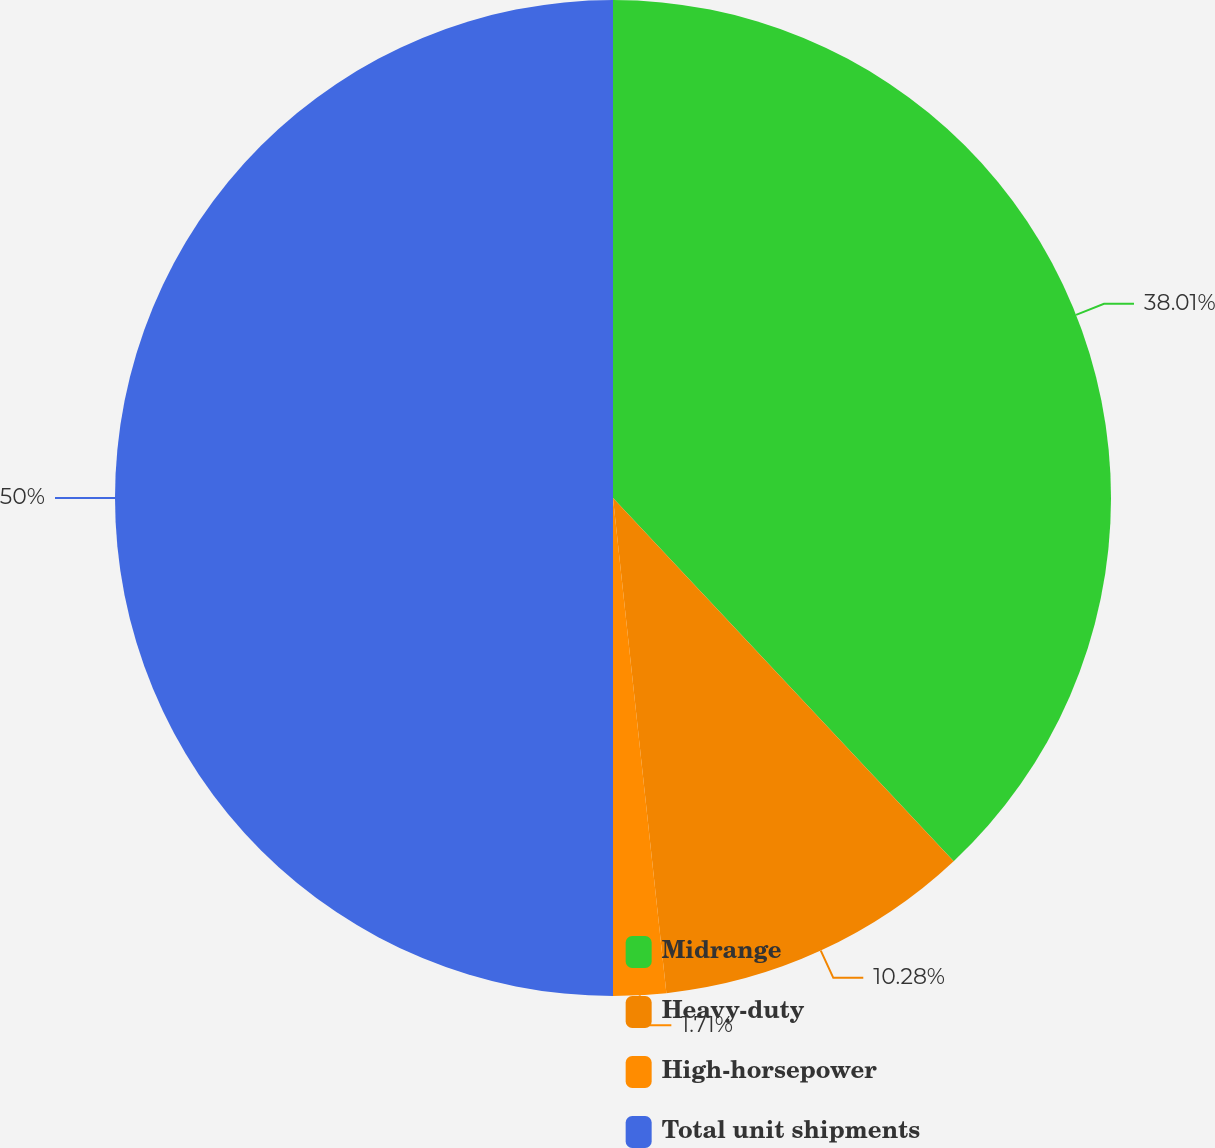<chart> <loc_0><loc_0><loc_500><loc_500><pie_chart><fcel>Midrange<fcel>Heavy-duty<fcel>High-horsepower<fcel>Total unit shipments<nl><fcel>38.01%<fcel>10.28%<fcel>1.71%<fcel>50.0%<nl></chart> 